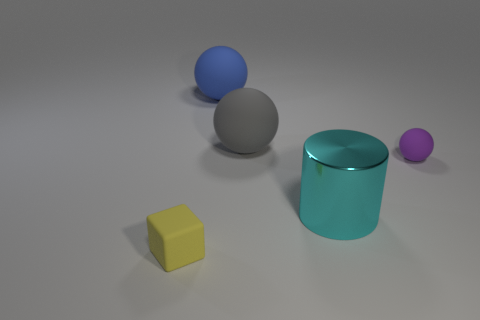What number of large objects are purple rubber spheres or brown objects?
Offer a terse response. 0. There is a block that is made of the same material as the tiny purple thing; what is its color?
Offer a very short reply. Yellow. There is a tiny object that is in front of the tiny ball; does it have the same shape as the small matte object that is behind the yellow rubber object?
Your answer should be very brief. No. What number of matte objects are either large blue objects or purple objects?
Your response must be concise. 2. Is there anything else that is the same shape as the yellow matte thing?
Offer a terse response. No. There is a large thing that is in front of the purple sphere; what material is it?
Offer a very short reply. Metal. Do the tiny thing behind the small yellow matte cube and the large cyan cylinder have the same material?
Provide a short and direct response. No. How many objects are large blue balls or things that are behind the purple sphere?
Offer a terse response. 2. What is the size of the purple thing that is the same shape as the gray rubber thing?
Provide a succinct answer. Small. Is there anything else that has the same size as the blue thing?
Offer a very short reply. Yes. 